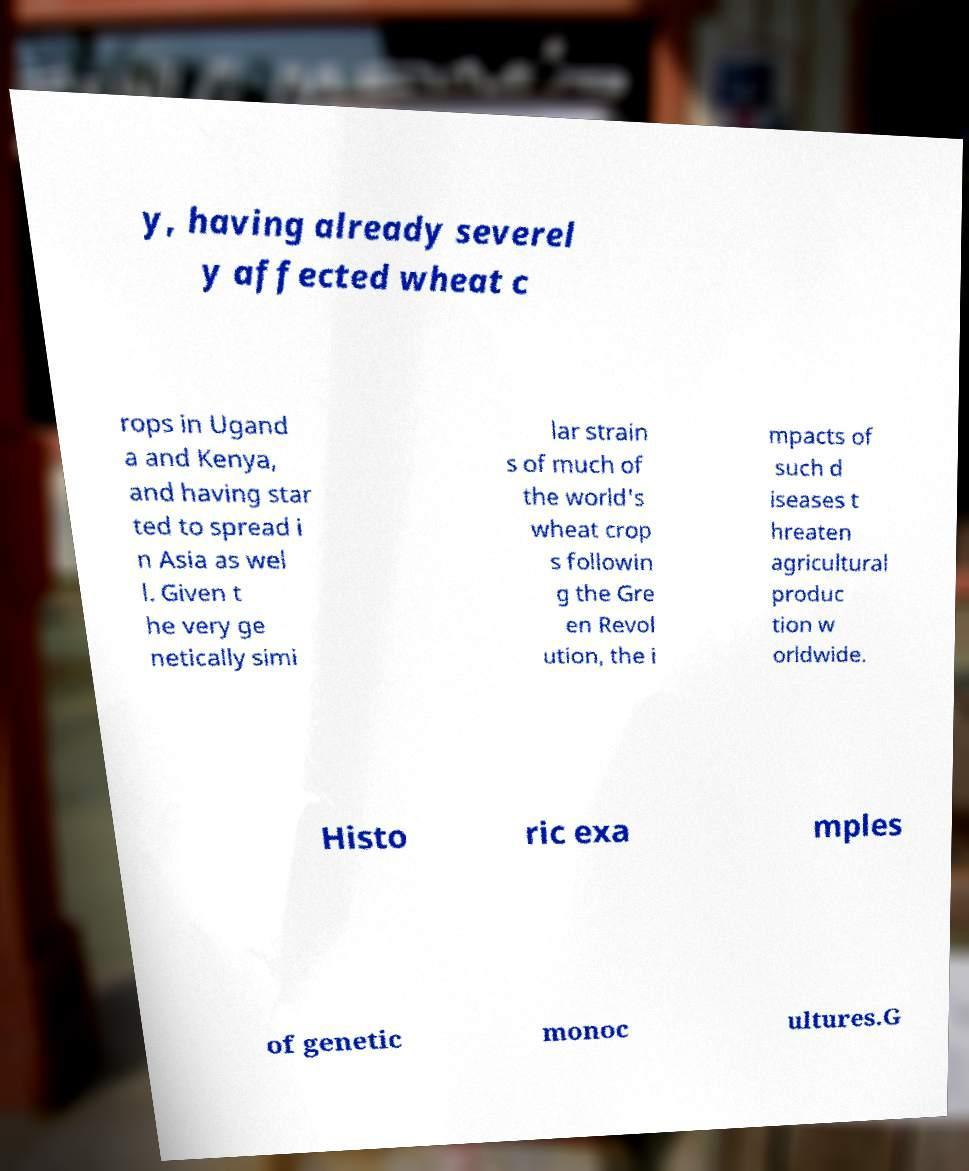For documentation purposes, I need the text within this image transcribed. Could you provide that? y, having already severel y affected wheat c rops in Ugand a and Kenya, and having star ted to spread i n Asia as wel l. Given t he very ge netically simi lar strain s of much of the world's wheat crop s followin g the Gre en Revol ution, the i mpacts of such d iseases t hreaten agricultural produc tion w orldwide. Histo ric exa mples of genetic monoc ultures.G 